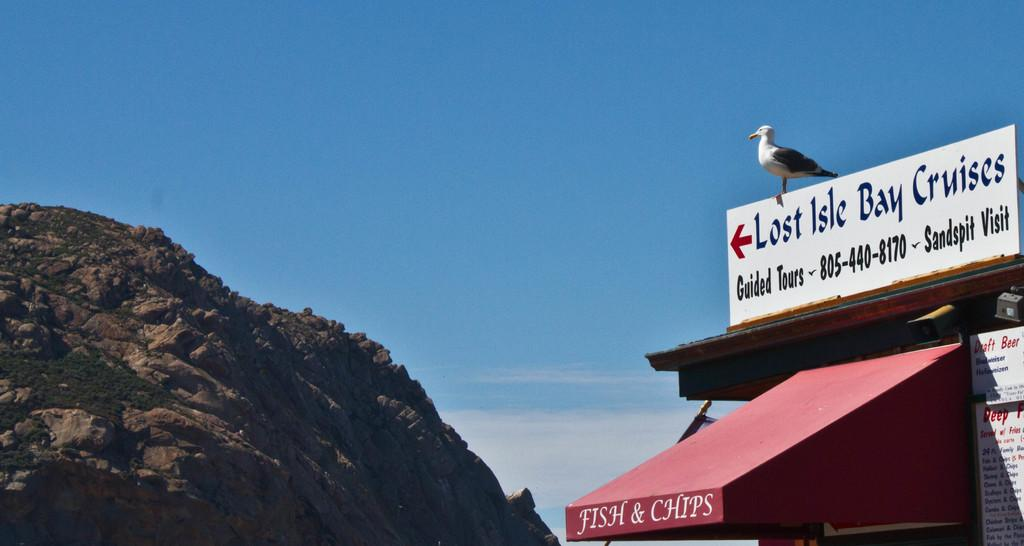<image>
Summarize the visual content of the image. a seagull sitting on top of a sign that says 'lost isle bay cruises' 